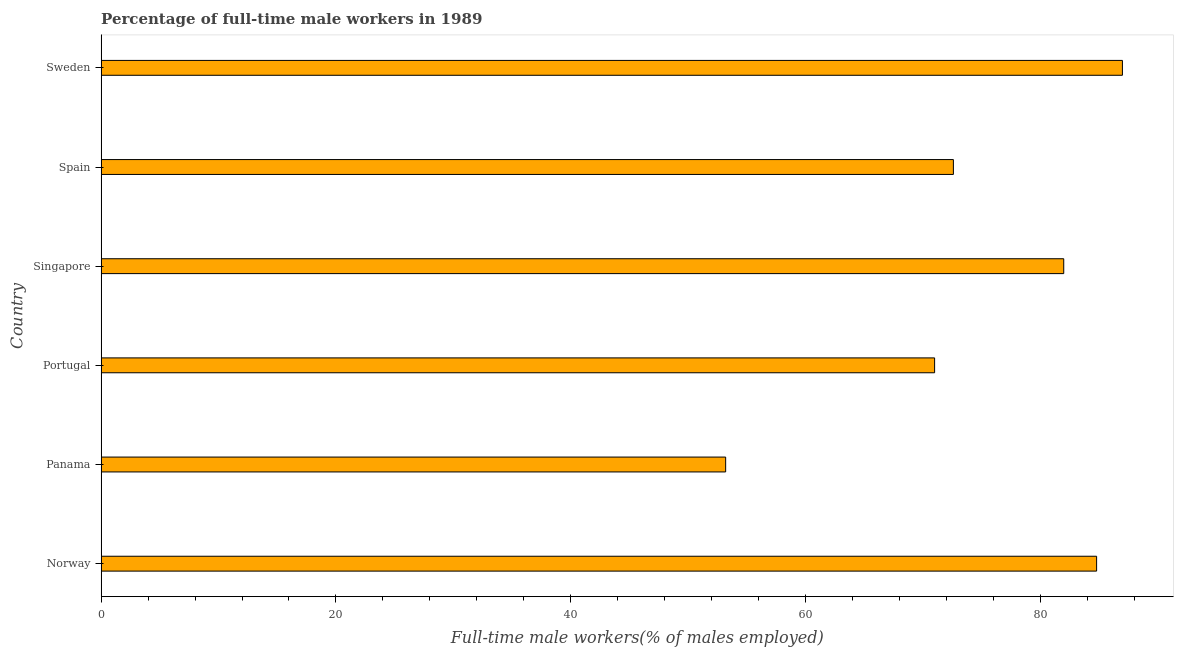What is the title of the graph?
Keep it short and to the point. Percentage of full-time male workers in 1989. What is the label or title of the X-axis?
Give a very brief answer. Full-time male workers(% of males employed). What is the label or title of the Y-axis?
Make the answer very short. Country. What is the percentage of full-time male workers in Spain?
Keep it short and to the point. 72.6. Across all countries, what is the minimum percentage of full-time male workers?
Make the answer very short. 53.2. In which country was the percentage of full-time male workers minimum?
Keep it short and to the point. Panama. What is the sum of the percentage of full-time male workers?
Offer a very short reply. 450.6. What is the difference between the percentage of full-time male workers in Norway and Singapore?
Your answer should be compact. 2.8. What is the average percentage of full-time male workers per country?
Offer a very short reply. 75.1. What is the median percentage of full-time male workers?
Your answer should be compact. 77.3. In how many countries, is the percentage of full-time male workers greater than 8 %?
Your answer should be compact. 6. What is the ratio of the percentage of full-time male workers in Norway to that in Panama?
Your answer should be very brief. 1.59. Is the percentage of full-time male workers in Panama less than that in Portugal?
Provide a short and direct response. Yes. What is the difference between the highest and the lowest percentage of full-time male workers?
Provide a succinct answer. 33.8. In how many countries, is the percentage of full-time male workers greater than the average percentage of full-time male workers taken over all countries?
Your answer should be compact. 3. How many bars are there?
Keep it short and to the point. 6. Are all the bars in the graph horizontal?
Your answer should be very brief. Yes. How many countries are there in the graph?
Your answer should be very brief. 6. What is the Full-time male workers(% of males employed) of Norway?
Make the answer very short. 84.8. What is the Full-time male workers(% of males employed) in Panama?
Offer a very short reply. 53.2. What is the Full-time male workers(% of males employed) in Singapore?
Provide a short and direct response. 82. What is the Full-time male workers(% of males employed) in Spain?
Offer a terse response. 72.6. What is the Full-time male workers(% of males employed) in Sweden?
Give a very brief answer. 87. What is the difference between the Full-time male workers(% of males employed) in Norway and Panama?
Your response must be concise. 31.6. What is the difference between the Full-time male workers(% of males employed) in Norway and Spain?
Provide a short and direct response. 12.2. What is the difference between the Full-time male workers(% of males employed) in Norway and Sweden?
Keep it short and to the point. -2.2. What is the difference between the Full-time male workers(% of males employed) in Panama and Portugal?
Your response must be concise. -17.8. What is the difference between the Full-time male workers(% of males employed) in Panama and Singapore?
Your response must be concise. -28.8. What is the difference between the Full-time male workers(% of males employed) in Panama and Spain?
Provide a short and direct response. -19.4. What is the difference between the Full-time male workers(% of males employed) in Panama and Sweden?
Offer a terse response. -33.8. What is the difference between the Full-time male workers(% of males employed) in Singapore and Spain?
Provide a short and direct response. 9.4. What is the difference between the Full-time male workers(% of males employed) in Singapore and Sweden?
Give a very brief answer. -5. What is the difference between the Full-time male workers(% of males employed) in Spain and Sweden?
Offer a terse response. -14.4. What is the ratio of the Full-time male workers(% of males employed) in Norway to that in Panama?
Keep it short and to the point. 1.59. What is the ratio of the Full-time male workers(% of males employed) in Norway to that in Portugal?
Your response must be concise. 1.19. What is the ratio of the Full-time male workers(% of males employed) in Norway to that in Singapore?
Give a very brief answer. 1.03. What is the ratio of the Full-time male workers(% of males employed) in Norway to that in Spain?
Provide a short and direct response. 1.17. What is the ratio of the Full-time male workers(% of males employed) in Panama to that in Portugal?
Your answer should be very brief. 0.75. What is the ratio of the Full-time male workers(% of males employed) in Panama to that in Singapore?
Ensure brevity in your answer.  0.65. What is the ratio of the Full-time male workers(% of males employed) in Panama to that in Spain?
Your answer should be compact. 0.73. What is the ratio of the Full-time male workers(% of males employed) in Panama to that in Sweden?
Give a very brief answer. 0.61. What is the ratio of the Full-time male workers(% of males employed) in Portugal to that in Singapore?
Your answer should be compact. 0.87. What is the ratio of the Full-time male workers(% of males employed) in Portugal to that in Spain?
Offer a very short reply. 0.98. What is the ratio of the Full-time male workers(% of males employed) in Portugal to that in Sweden?
Your answer should be compact. 0.82. What is the ratio of the Full-time male workers(% of males employed) in Singapore to that in Spain?
Your response must be concise. 1.13. What is the ratio of the Full-time male workers(% of males employed) in Singapore to that in Sweden?
Make the answer very short. 0.94. What is the ratio of the Full-time male workers(% of males employed) in Spain to that in Sweden?
Keep it short and to the point. 0.83. 